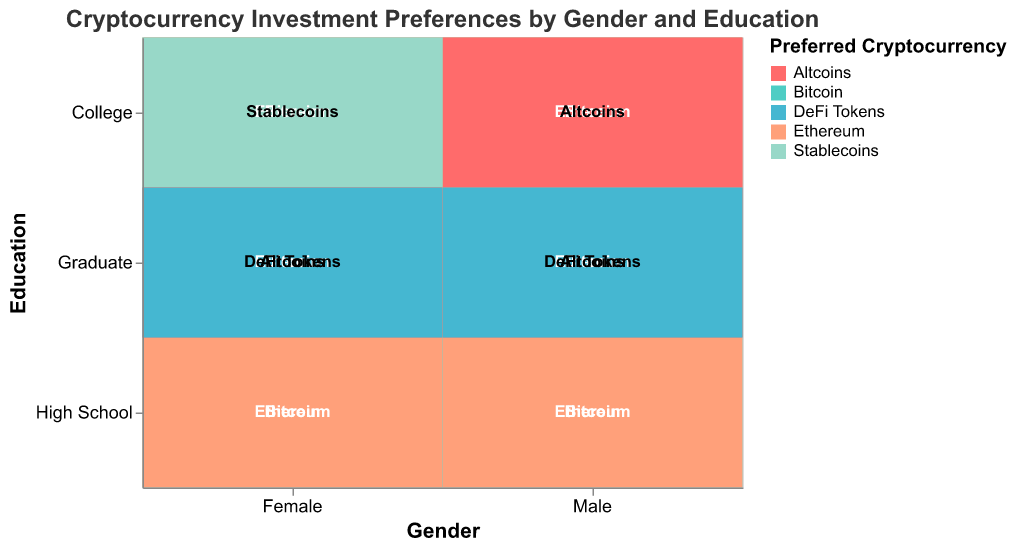What's the title of the plot? The title is located at the top of the plot. The text reads "Cryptocurrency Investment Preferences by Gender and Education".
Answer: Cryptocurrency Investment Preferences by Gender and Education Which gender and education level combination has the most diverse preferences for cryptocurrencies? The diversity of preferences can be observed by noting the number of different cryptocurrencies preferred. For males with a graduate education level, there are four different preferences (Bitcoin, Ethereum, Altcoins, DeFi Tokens).
Answer: Male, Graduate How many different preferred cryptocurrencies are represented among females with a college education? By looking at the segment for females with college education, we see three different preferred cryptocurrencies (Bitcoin, Ethereum, Stablecoins).
Answer: 3 Do males or females have DeFi Tokens as a preferred cryptocurrency, and at what education level? DeFi Tokens can be identified by their color and text label in the visualization. They are preferred by both males and females at a Graduate education level.
Answer: Both, Graduate How does the preference for Bitcoin compare between males and females at the graduate education level? By comparing the segments for both genders at the graduate level, we observe that both males and females show a preference for Bitcoin. The size of the segments can help compare proportions, but both are present.
Answer: Both have a preference What are the preferred cryptocurrencies for males with a high school education? The segments for males with a high school education show two different cryptocurrencies which are labeled and colored distinctively as Bitcoin and Ethereum.
Answer: Bitcoin, Ethereum Which education level among females shows a preference for Stablecoins? Observing the plot, we see Stablecoins labeled for the college education level among females.
Answer: College Are there any education levels without a preference for Altcoins among both genders? By scanning the plot for Altcoins across all education levels, we observe that High School education level for both genders does not include Altcoins.
Answer: High School What cryptocurrency appears most frequently as a preferred choice across all categories? By counting occurrences of each cryptocurrency preference across all gender and education levels, Bitcoin is visibly the most frequent due to its presence in every educational category for both genders.
Answer: Bitcoin Is there a gender-based difference in the preference for Stablecoins? By looking for Stablecoins across gender categories, only females with a college education show a preference for Stablecoins, indicating a gender-based difference in preference for this cryptocurrency.
Answer: Yes, females with college education 